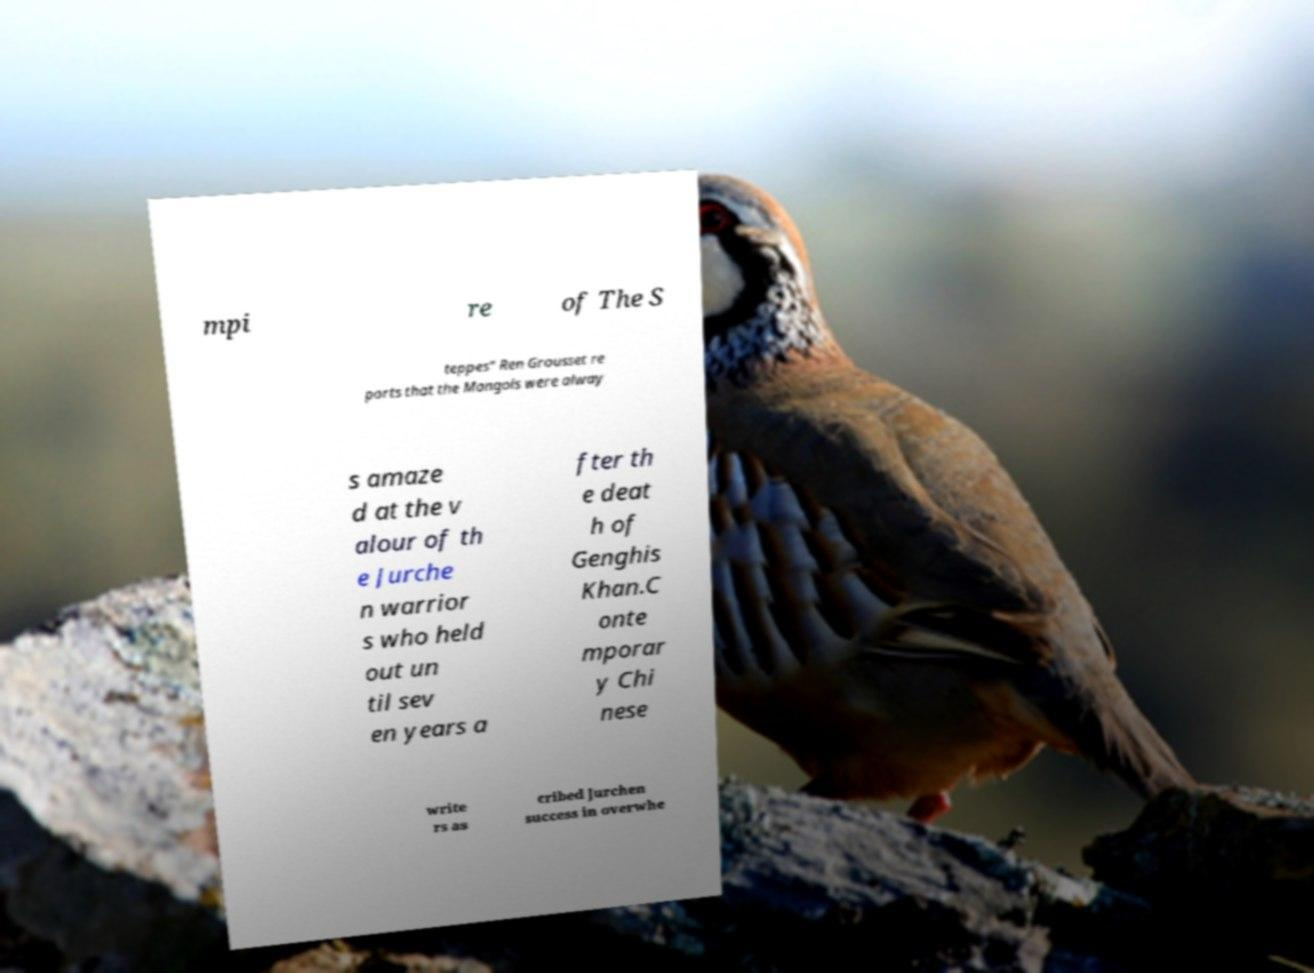Please identify and transcribe the text found in this image. mpi re of The S teppes" Ren Grousset re ports that the Mongols were alway s amaze d at the v alour of th e Jurche n warrior s who held out un til sev en years a fter th e deat h of Genghis Khan.C onte mporar y Chi nese write rs as cribed Jurchen success in overwhe 